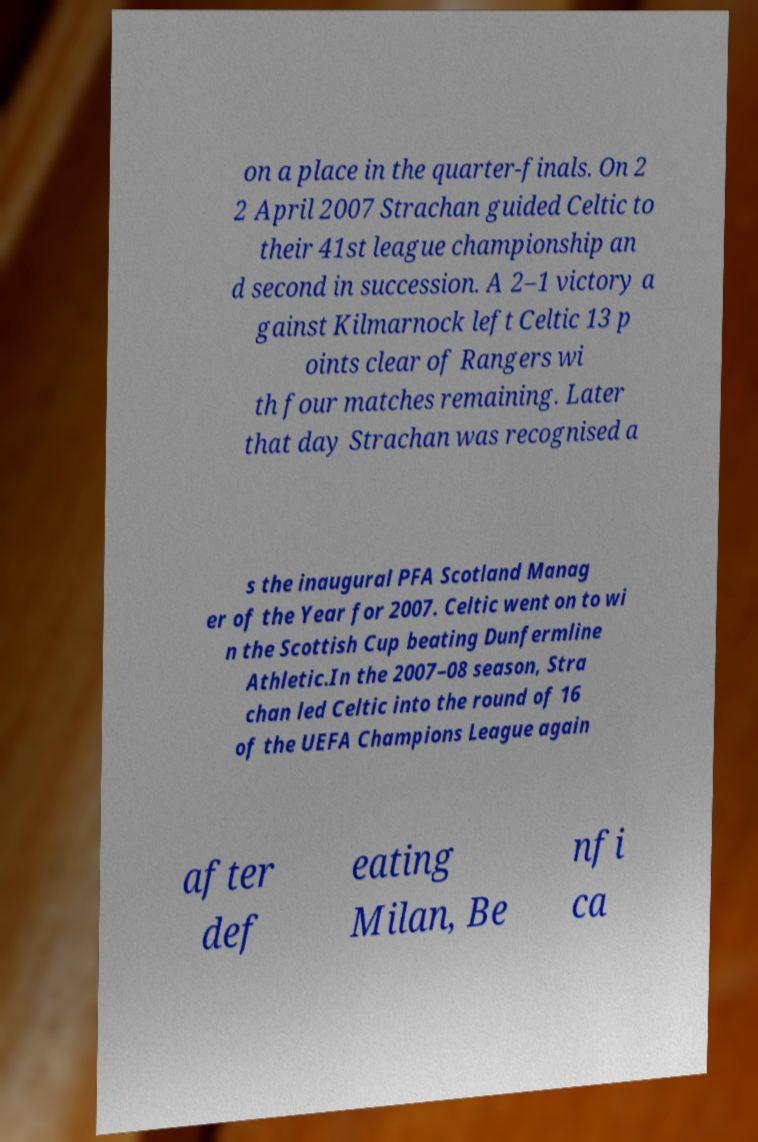What messages or text are displayed in this image? I need them in a readable, typed format. on a place in the quarter-finals. On 2 2 April 2007 Strachan guided Celtic to their 41st league championship an d second in succession. A 2–1 victory a gainst Kilmarnock left Celtic 13 p oints clear of Rangers wi th four matches remaining. Later that day Strachan was recognised a s the inaugural PFA Scotland Manag er of the Year for 2007. Celtic went on to wi n the Scottish Cup beating Dunfermline Athletic.In the 2007–08 season, Stra chan led Celtic into the round of 16 of the UEFA Champions League again after def eating Milan, Be nfi ca 